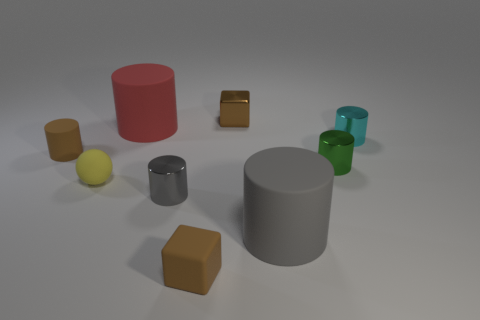Is there a tiny rubber thing of the same color as the matte block?
Ensure brevity in your answer.  Yes. What material is the small cylinder that is both behind the small green thing and left of the gray matte cylinder?
Provide a succinct answer. Rubber. Is there any other thing that is the same shape as the tiny yellow object?
Give a very brief answer. No. There is a tiny block that is made of the same material as the sphere; what color is it?
Provide a succinct answer. Brown. How many objects are either small red metal objects or tiny gray cylinders?
Your answer should be compact. 1. Does the green metallic thing have the same size as the brown thing to the left of the yellow matte thing?
Offer a terse response. Yes. There is a tiny sphere in front of the small metal cube to the right of the yellow matte ball that is to the right of the tiny matte cylinder; what is its color?
Provide a short and direct response. Yellow. What color is the ball?
Offer a very short reply. Yellow. Is the number of big rubber cylinders that are behind the red object greater than the number of gray rubber cylinders behind the metallic cube?
Your response must be concise. No. Does the small gray thing have the same shape as the tiny brown rubber thing that is behind the yellow object?
Your response must be concise. Yes. 